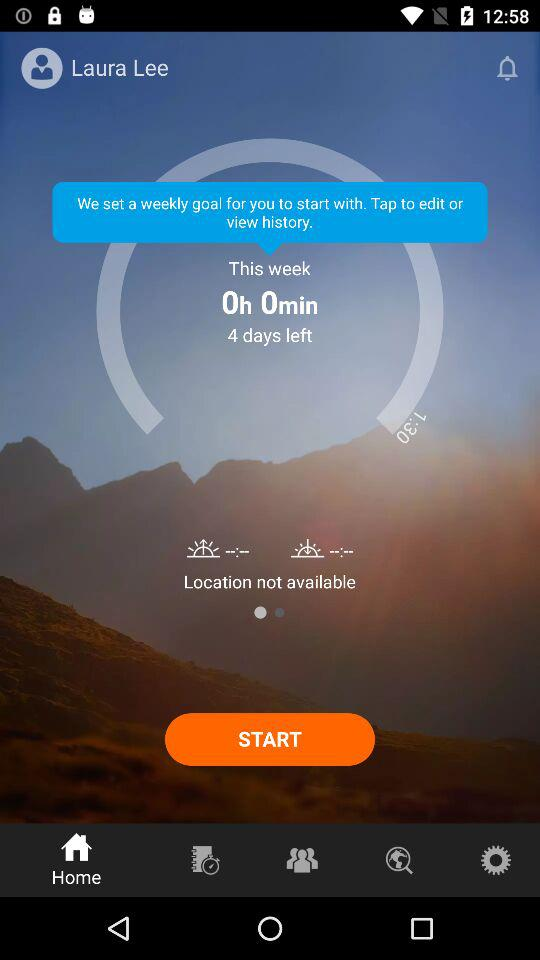What is the selected tab? The selected tab is "Home". 